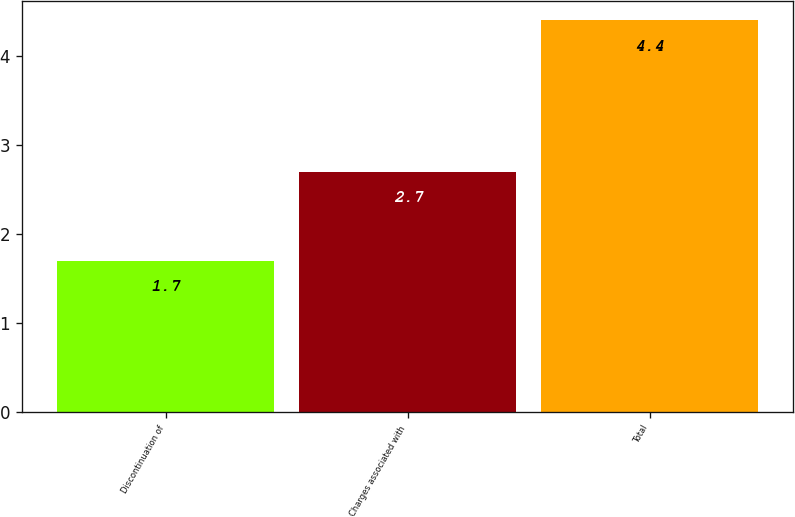Convert chart to OTSL. <chart><loc_0><loc_0><loc_500><loc_500><bar_chart><fcel>Discontinuation of<fcel>Charges associated with<fcel>Total<nl><fcel>1.7<fcel>2.7<fcel>4.4<nl></chart> 